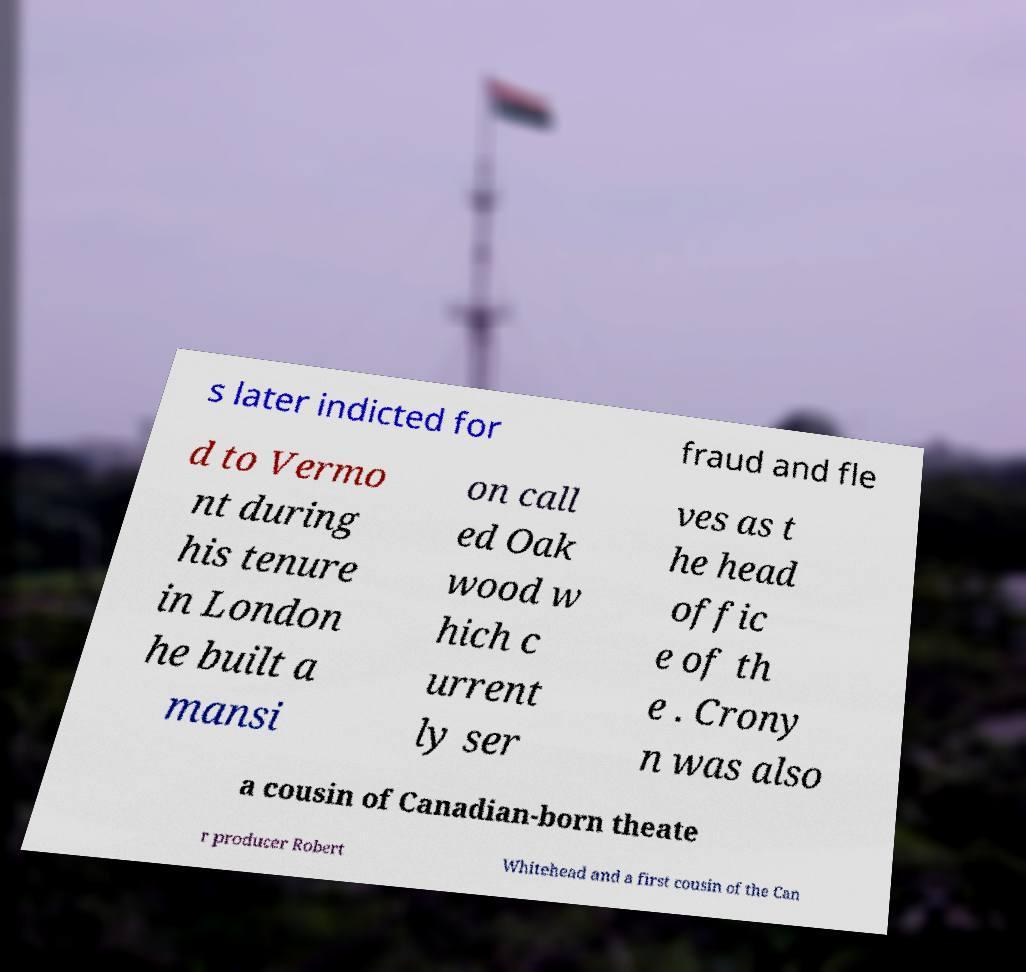Please identify and transcribe the text found in this image. s later indicted for fraud and fle d to Vermo nt during his tenure in London he built a mansi on call ed Oak wood w hich c urrent ly ser ves as t he head offic e of th e . Crony n was also a cousin of Canadian-born theate r producer Robert Whitehead and a first cousin of the Can 